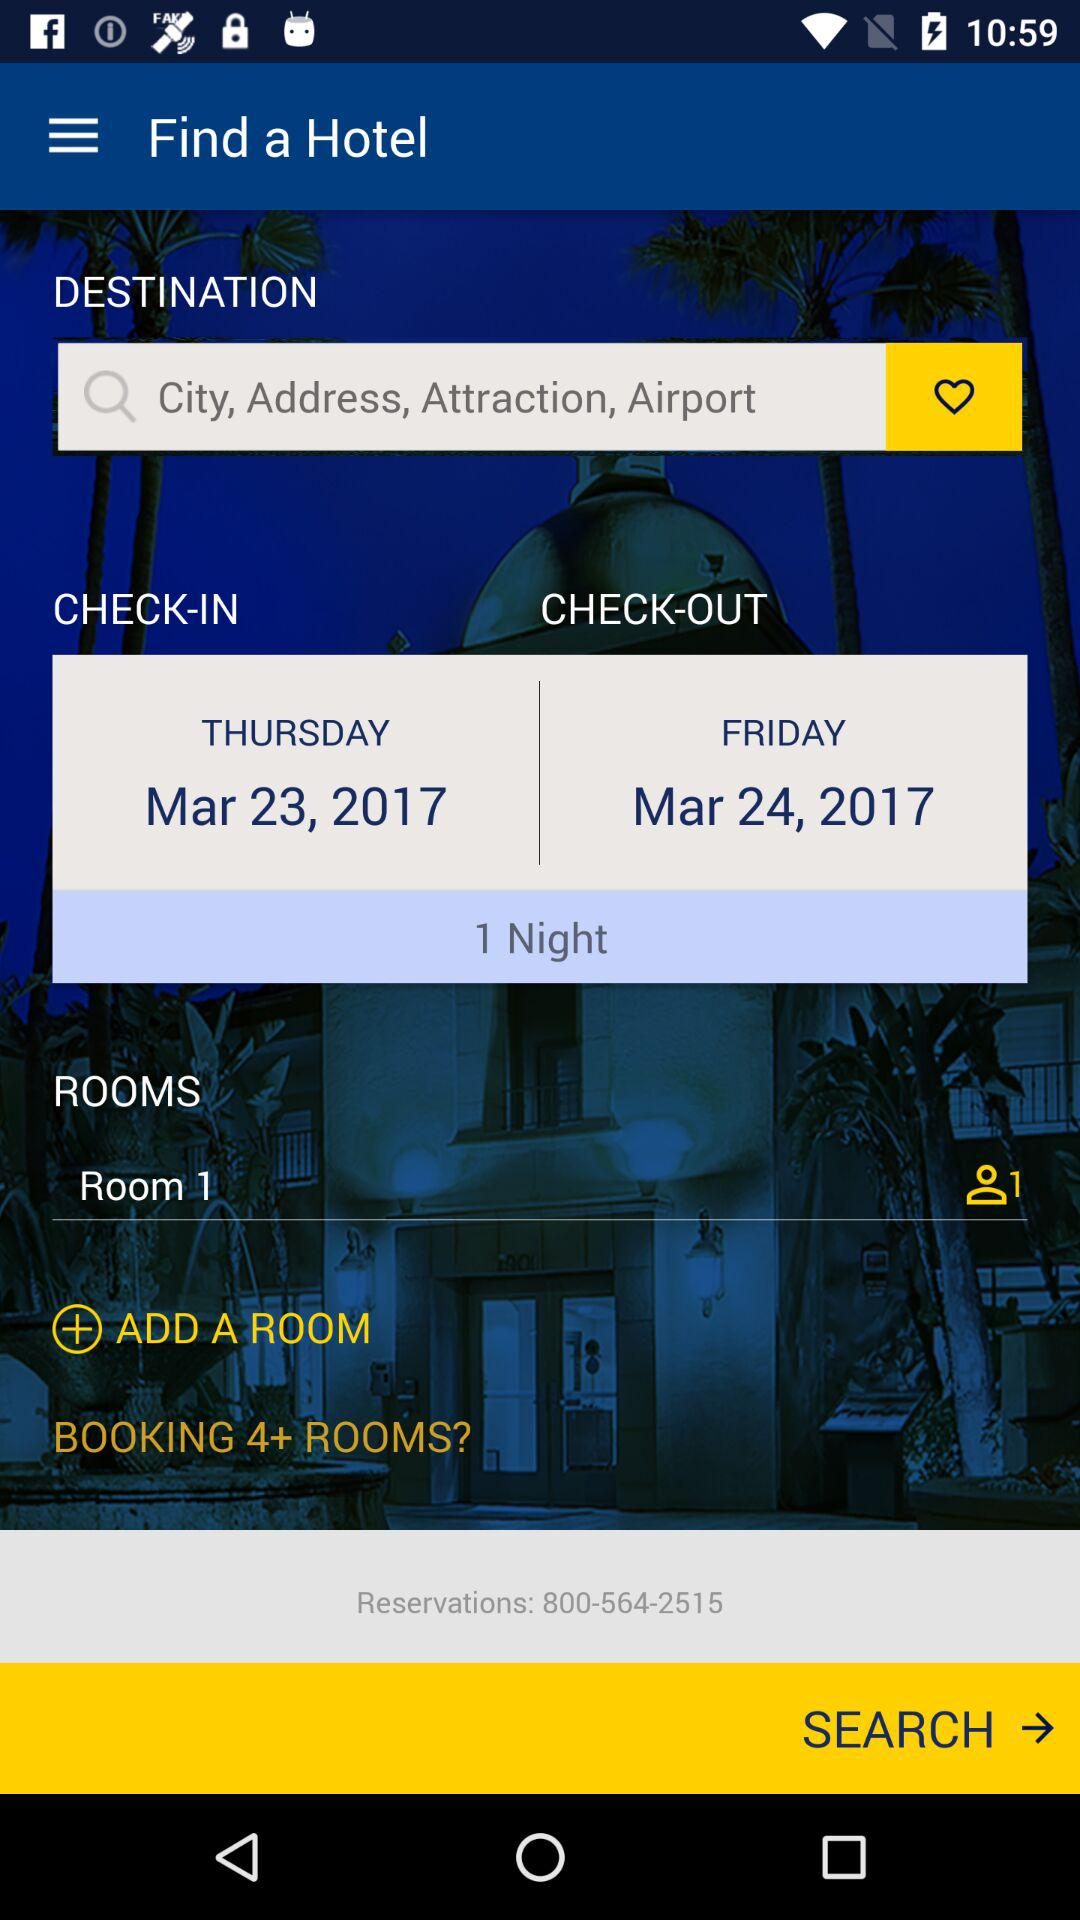How many rooms were selected? There was 1 room selected. 